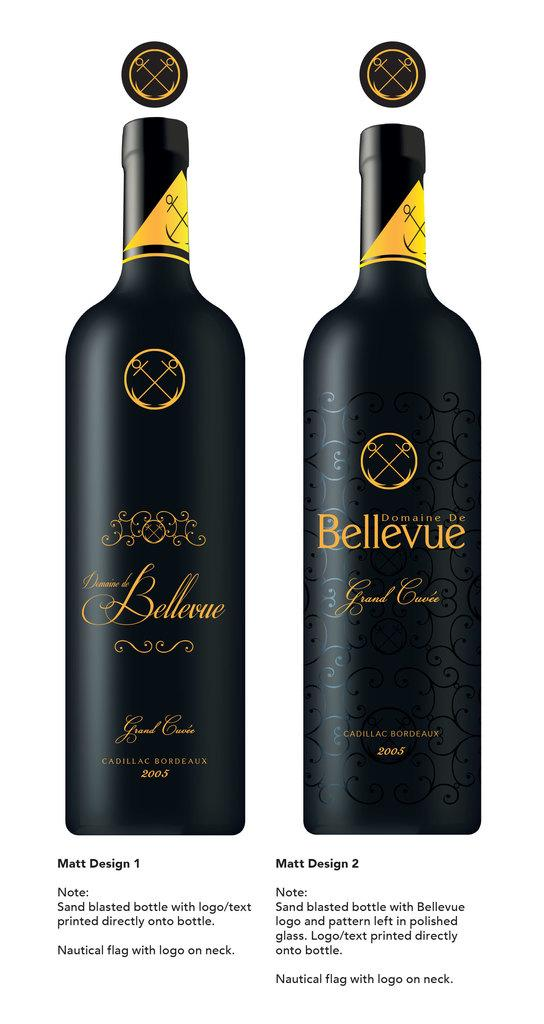<image>
Describe the image concisely. An ad for Bellevue wine is shown with information below the bottles. 